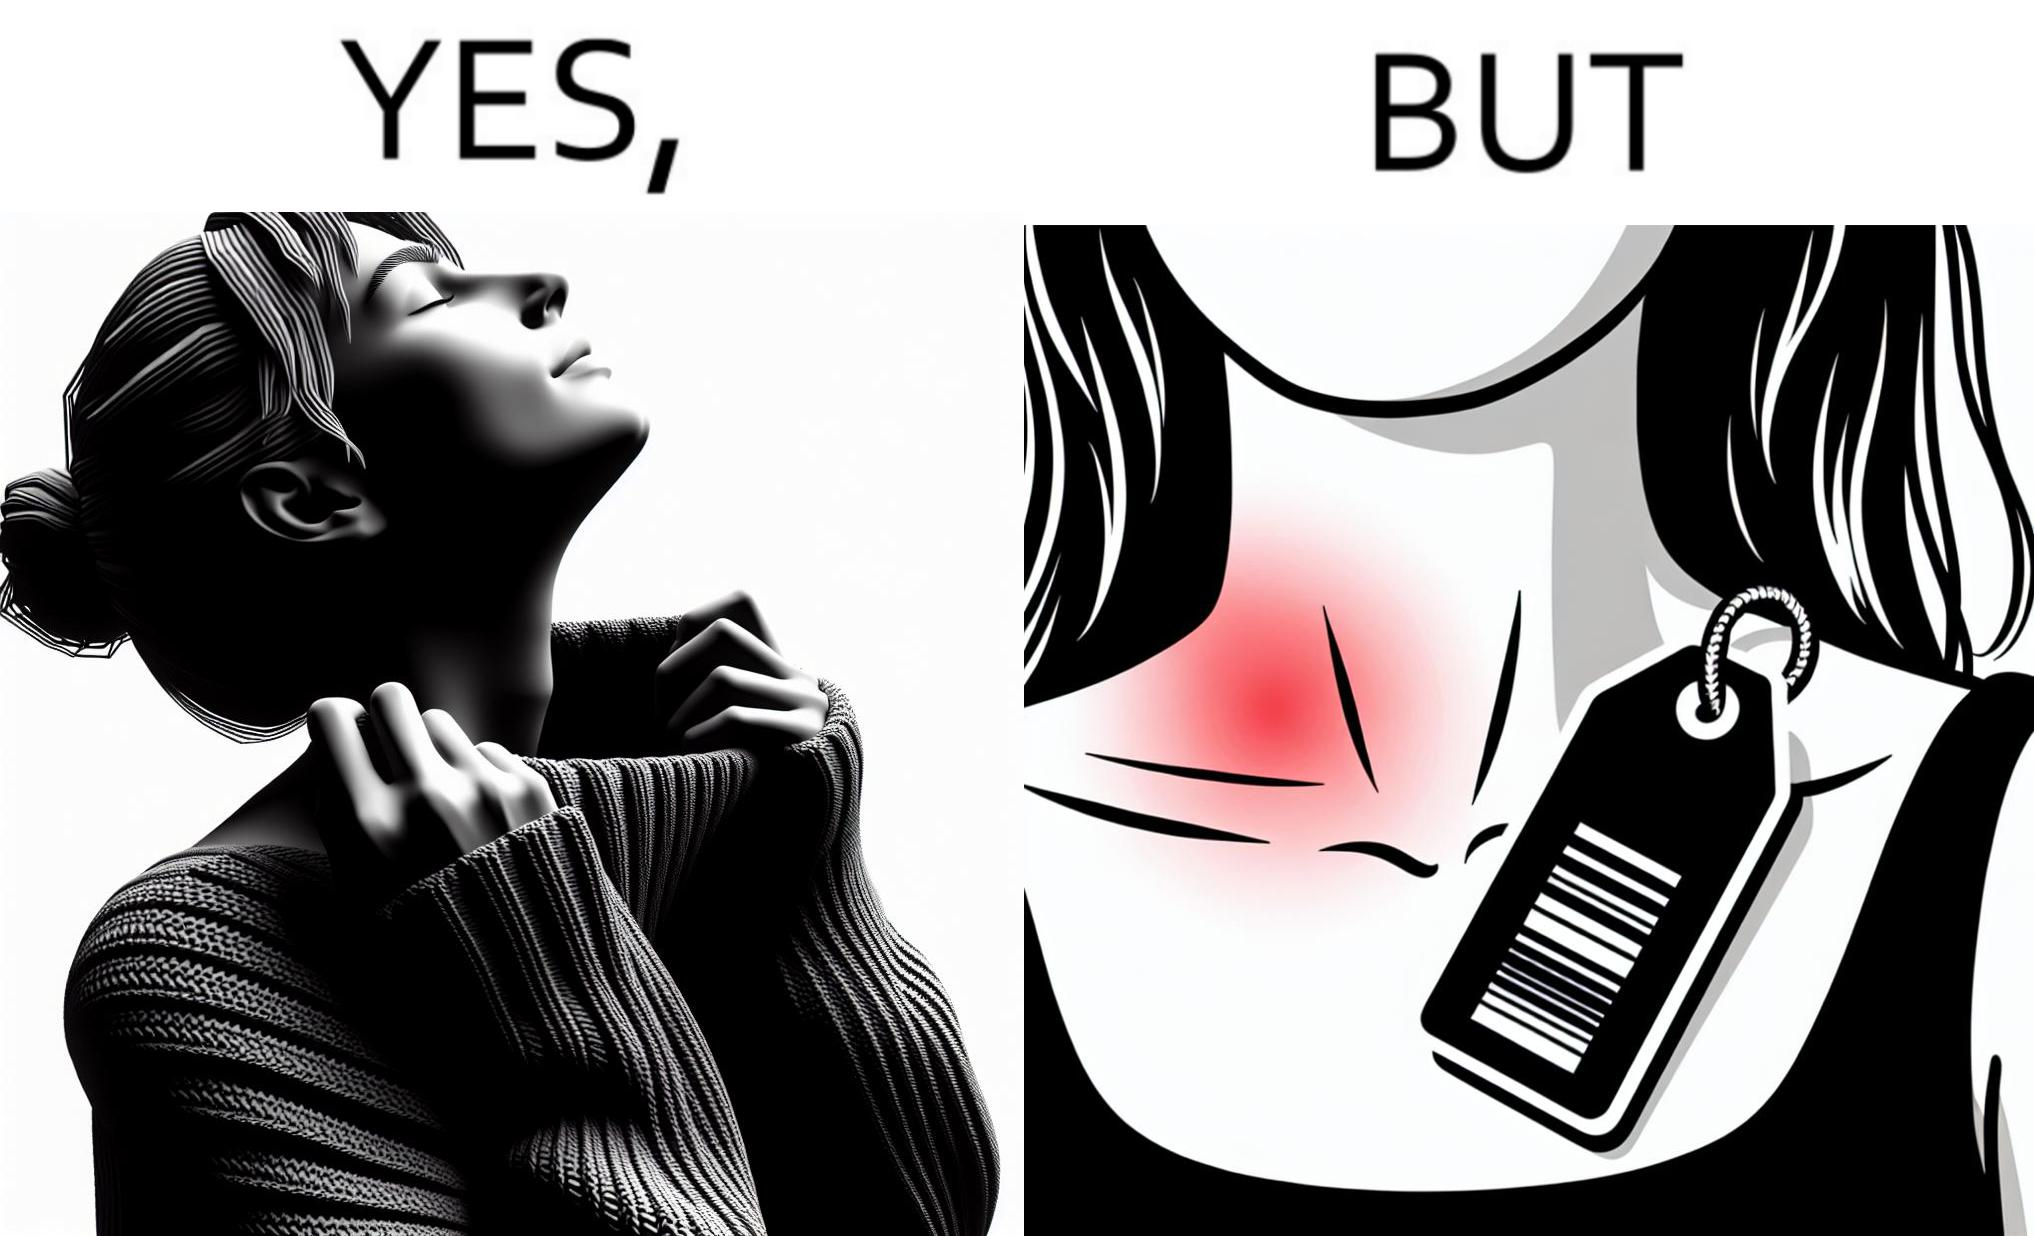Explain why this image is satirical. The images are funny since it shows how even though sweaters and other clothings provide much comfort, a tiny manufacturers tag ends up causing the user a lot of discomfort due to constant scratching 